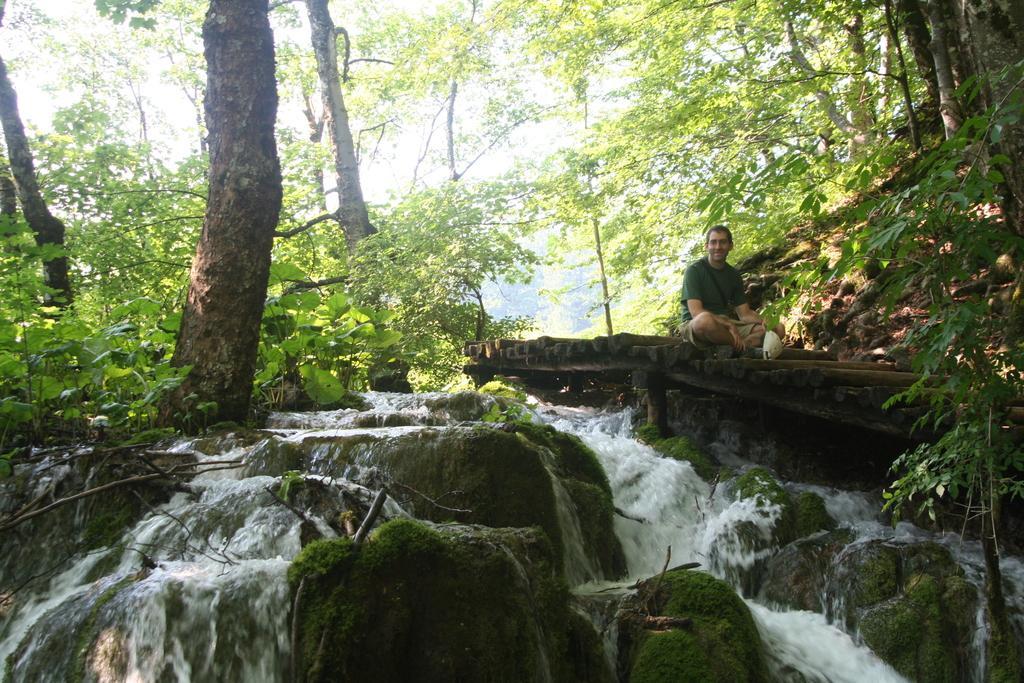Describe this image in one or two sentences. This image is taken outdoors. In this image there are many trees and plants on the ground. In the middle of the image a man is sitting on the wooden bridge. At the bottom of the image there are many rocks and water is flowing. 